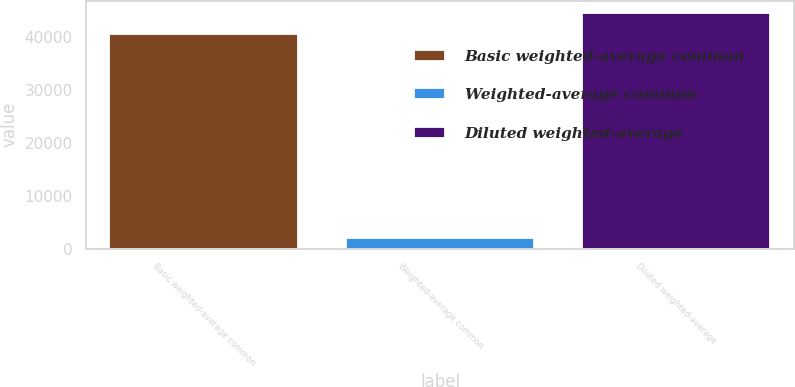<chart> <loc_0><loc_0><loc_500><loc_500><bar_chart><fcel>Basic weighted-average common<fcel>Weighted-average common<fcel>Diluted weighted-average<nl><fcel>40516<fcel>2077<fcel>44567.6<nl></chart> 